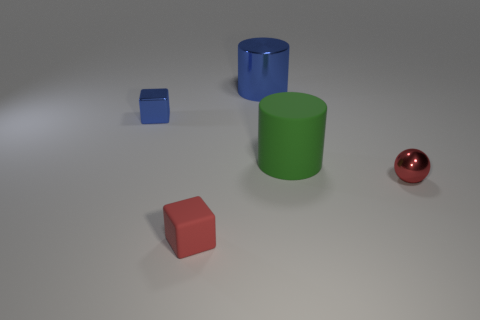What shape is the other object that is the same color as the small matte thing?
Ensure brevity in your answer.  Sphere. Is there any other thing that is the same color as the big rubber thing?
Your response must be concise. No. Is the number of large green matte objects that are behind the small shiny sphere greater than the number of purple shiny objects?
Your response must be concise. Yes. Are there any small green matte balls?
Your response must be concise. No. How many other objects are the same shape as the tiny blue shiny thing?
Ensure brevity in your answer.  1. Is the color of the small block on the left side of the red cube the same as the rubber thing that is to the left of the green rubber cylinder?
Provide a succinct answer. No. There is a shiny object that is in front of the tiny block behind the small red rubber thing left of the small red shiny object; what is its size?
Offer a very short reply. Small. There is a metal thing that is both to the right of the red block and behind the small red shiny object; what is its shape?
Give a very brief answer. Cylinder. Is the number of tiny blue metallic blocks that are behind the shiny cylinder the same as the number of large things that are behind the blue metallic block?
Offer a terse response. No. Is there a tiny blue cylinder made of the same material as the green object?
Your answer should be compact. No. 